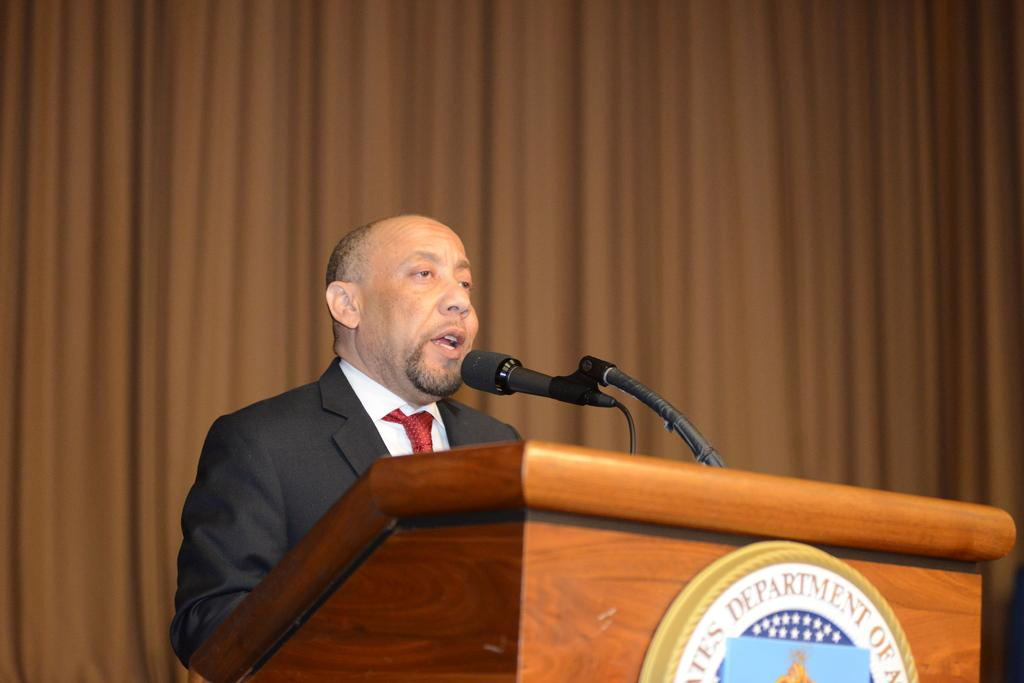What is the main subject of the image? There is a person in the image. What is the person wearing? The person is wearing a suit. What is the person doing in the image? The person is speaking. What object is present to help amplify the person's voice? There is a microphone in the image. What is the microphone attached to in the image? There is a microphone stand in the image. What can be seen in the background of the image? There are brown curtains in the background of the image. What type of hydrant can be seen in the image? There is no hydrant present in the image. How many cushions are visible on the stage in the image? There is no stage or cushions present in the image. 